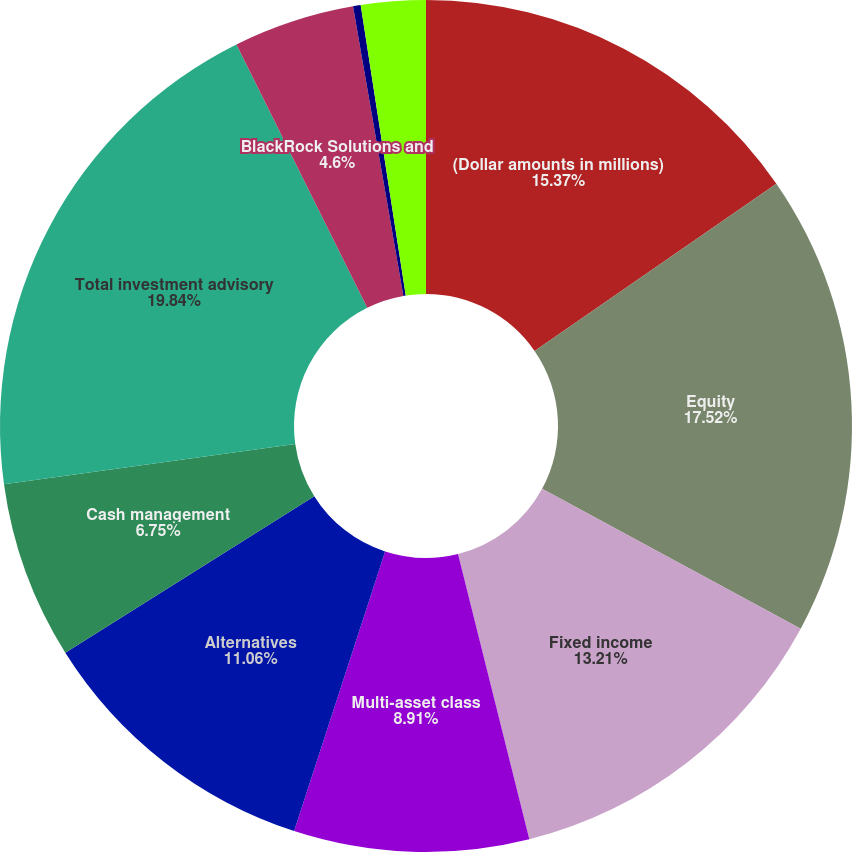Convert chart to OTSL. <chart><loc_0><loc_0><loc_500><loc_500><pie_chart><fcel>(Dollar amounts in millions)<fcel>Equity<fcel>Fixed income<fcel>Multi-asset class<fcel>Alternatives<fcel>Cash management<fcel>Total investment advisory<fcel>BlackRock Solutions and<fcel>Distribution fees<fcel>Other revenue<nl><fcel>15.37%<fcel>17.52%<fcel>13.21%<fcel>8.91%<fcel>11.06%<fcel>6.75%<fcel>19.84%<fcel>4.6%<fcel>0.29%<fcel>2.45%<nl></chart> 